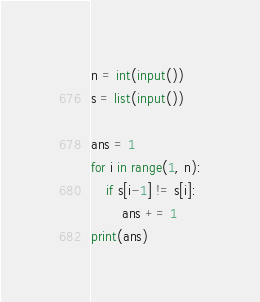Convert code to text. <code><loc_0><loc_0><loc_500><loc_500><_Python_>n = int(input())
s = list(input())

ans = 1
for i in range(1, n):
    if s[i-1] != s[i]:
        ans += 1
print(ans)
</code> 